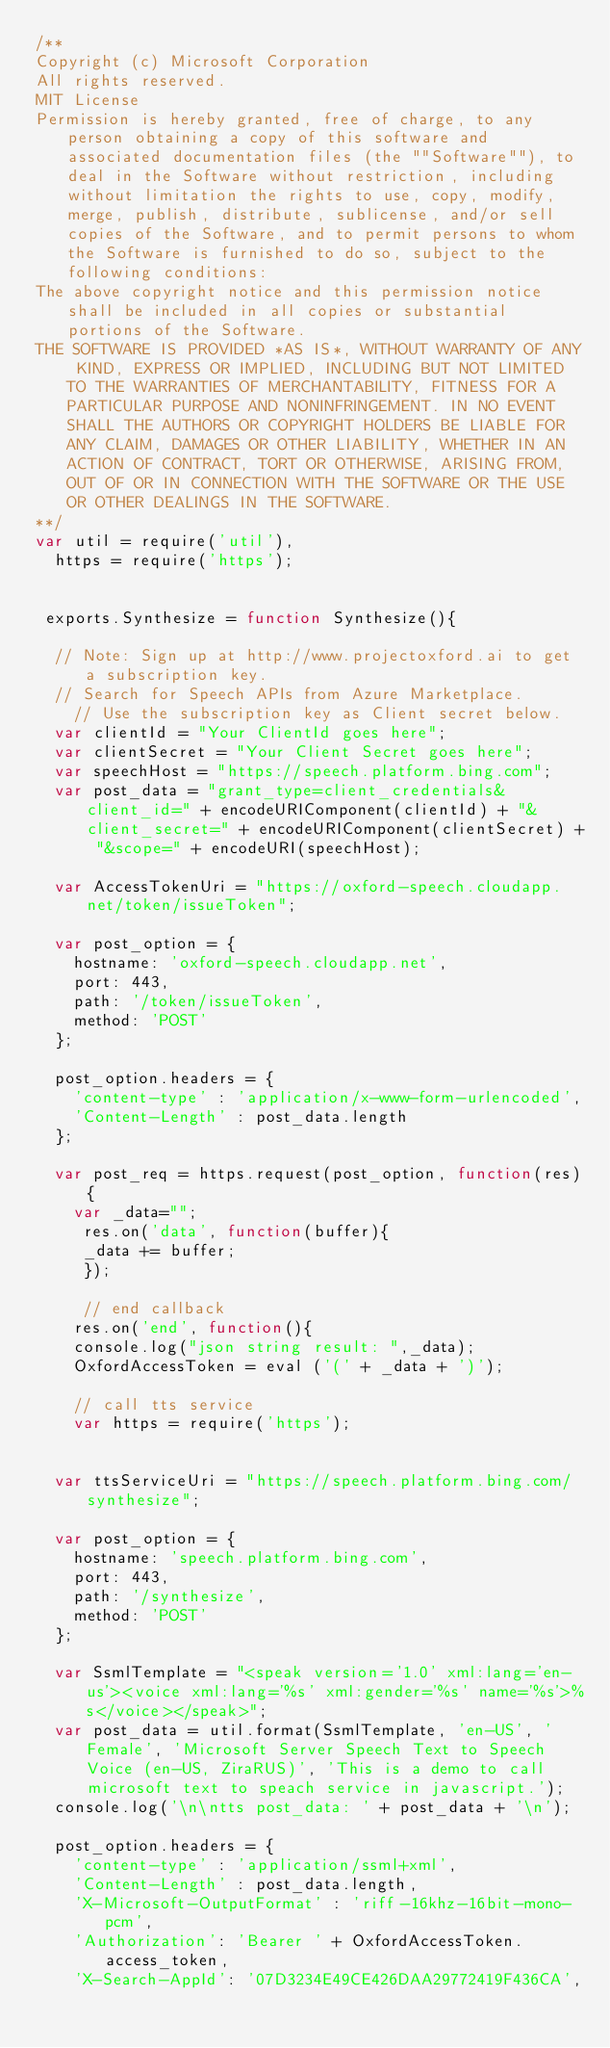Convert code to text. <code><loc_0><loc_0><loc_500><loc_500><_JavaScript_>/**
Copyright (c) Microsoft Corporation
All rights reserved. 
MIT License
Permission is hereby granted, free of charge, to any person obtaining a copy of this software and associated documentation files (the ""Software""), to deal in the Software without restriction, including without limitation the rights to use, copy, modify, merge, publish, distribute, sublicense, and/or sell copies of the Software, and to permit persons to whom the Software is furnished to do so, subject to the following conditions:
The above copyright notice and this permission notice shall be included in all copies or substantial portions of the Software.
THE SOFTWARE IS PROVIDED *AS IS*, WITHOUT WARRANTY OF ANY KIND, EXPRESS OR IMPLIED, INCLUDING BUT NOT LIMITED TO THE WARRANTIES OF MERCHANTABILITY, FITNESS FOR A PARTICULAR PURPOSE AND NONINFRINGEMENT. IN NO EVENT SHALL THE AUTHORS OR COPYRIGHT HOLDERS BE LIABLE FOR ANY CLAIM, DAMAGES OR OTHER LIABILITY, WHETHER IN AN ACTION OF CONTRACT, TORT OR OTHERWISE, ARISING FROM, OUT OF OR IN CONNECTION WITH THE SOFTWARE OR THE USE OR OTHER DEALINGS IN THE SOFTWARE.
**/
var util = require('util'),
  https = require('https');
 

 exports.Synthesize = function Synthesize(){

	// Note: Sign up at http://www.projectoxford.ai to get a subscription key.  
	// Search for Speech APIs from Azure Marketplace.  
    // Use the subscription key as Client secret below.
	var clientId = "Your ClientId goes here";
	var clientSecret = "Your Client Secret goes here";
	var speechHost = "https://speech.platform.bing.com";
	var post_data = "grant_type=client_credentials&client_id=" + encodeURIComponent(clientId) + "&client_secret=" + encodeURIComponent(clientSecret) + "&scope=" + encodeURI(speechHost);

	var AccessTokenUri = "https://oxford-speech.cloudapp.net/token/issueToken";

	var post_option = {
		hostname: 'oxford-speech.cloudapp.net',
		port: 443,
		path: '/token/issueToken',
		method: 'POST'
	};

	post_option.headers = {
		'content-type' : 'application/x-www-form-urlencoded',
		'Content-Length' : post_data.length	
	};

	var post_req = https.request(post_option, function(res){
	  var _data="";
	   res.on('data', function(buffer){
		 _data += buffer;
		 });
		 
		 // end callback
		res.on('end', function(){
		console.log("json string result: ",_data);
		OxfordAccessToken = eval ('(' + _data + ')');
		
		// call tts service
		var https = require('https');


	var ttsServiceUri = "https://speech.platform.bing.com/synthesize";

	var post_option = {
		hostname: 'speech.platform.bing.com',
		port: 443,
		path: '/synthesize',
		method: 'POST'
	};

	var SsmlTemplate = "<speak version='1.0' xml:lang='en-us'><voice xml:lang='%s' xml:gender='%s' name='%s'>%s</voice></speak>";
	var post_data = util.format(SsmlTemplate, 'en-US', 'Female', 'Microsoft Server Speech Text to Speech Voice (en-US, ZiraRUS)', 'This is a demo to call microsoft text to speach service in javascript.');
	console.log('\n\ntts post_data: ' + post_data + '\n');
	
	post_option.headers = {
		'content-type' : 'application/ssml+xml',
		'Content-Length' : post_data.length,
		'X-Microsoft-OutputFormat' : 'riff-16khz-16bit-mono-pcm',
		'Authorization': 'Bearer ' + OxfordAccessToken.access_token,
		'X-Search-AppId': '07D3234E49CE426DAA29772419F436CA',</code> 